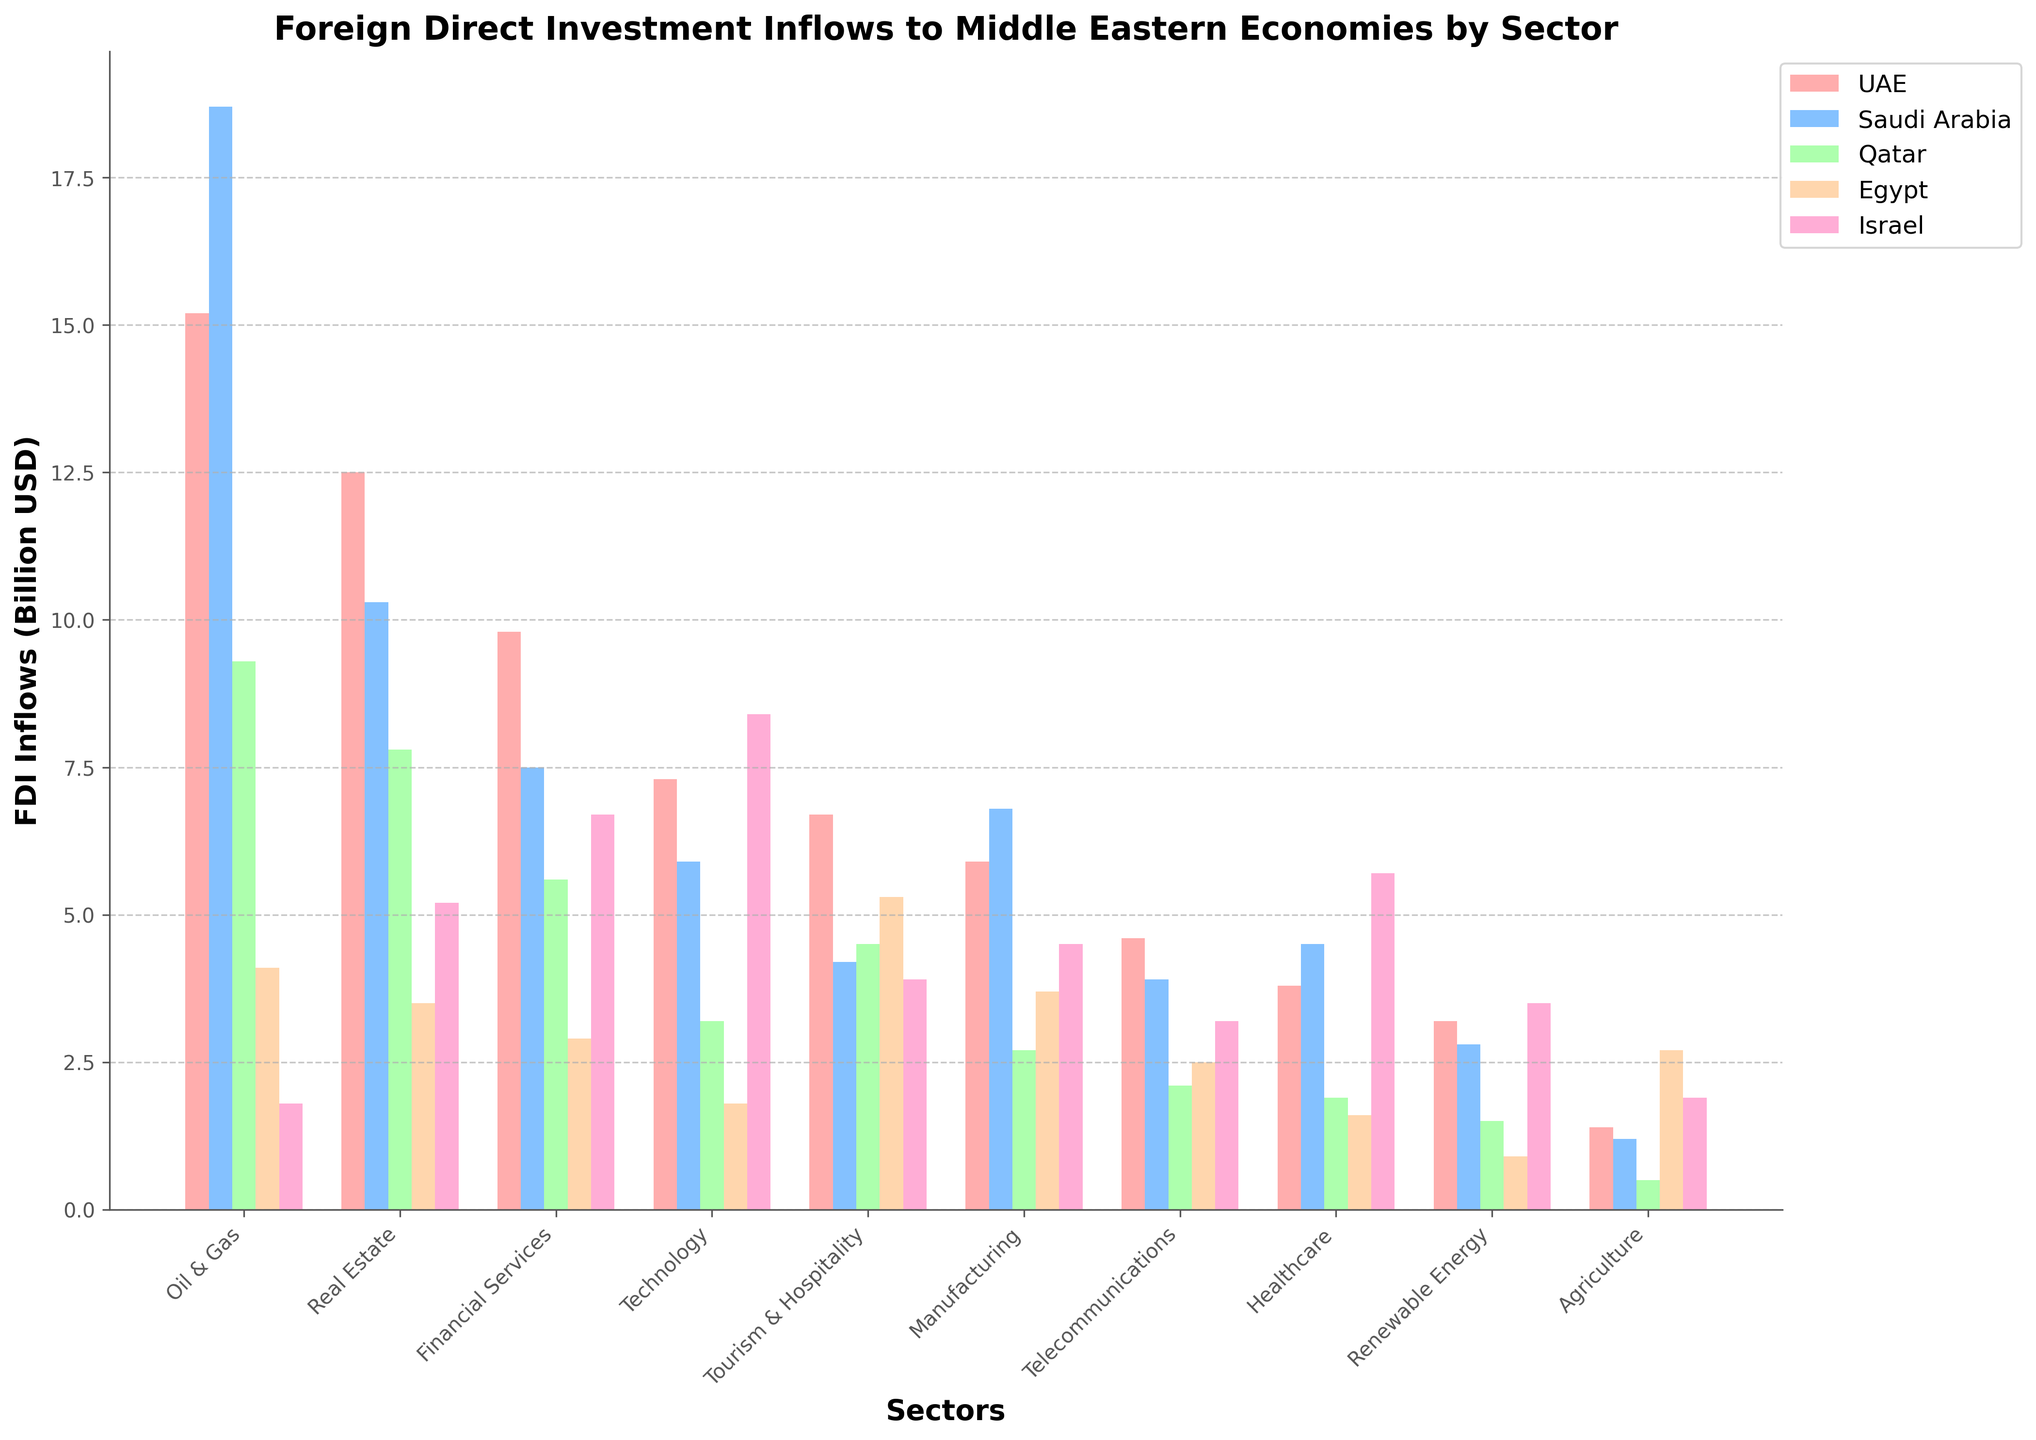Which sector receives the highest FDI inflows in the UAE? Look at the UAE's bars and identify the tallest one. Oil & Gas has the tallest bar.
Answer: Oil & Gas How do the FDI inflows for Financial Services compare between Egypt and Israel? Compare the height of the bars for Financial Services in Egypt (2.9) and Israel (6.7). Israel’s bar is taller.
Answer: Israel What's the sum of FDI inflows for Telecommunications and Agriculture in Saudi Arabia? Add the Saudi Arabia values for Telecommunications (3.9) and Agriculture (1.2): 3.9 + 1.2.
Answer: 5.1 Which country has the least FDI inflows in Technology? Find the shortest bar for Technology. Egypt has the shortest bar at 1.8.
Answer: Egypt Does the Manufacturing sector receive more FDI inflows than Renewable Energy in Qatar? Compare Manufacturing (2.7) and Renewable Energy (1.5) in Qatar. Manufacturing has higher values.
Answer: Yes Is the FDI inflow in Real Estate larger than in Tourism & Hospitality in Israel? Compare Real Estate (5.2) and Tourism & Hospitality (3.9) in Israel. Real Estate has the larger bar.
Answer: Yes What is the average FDI inflow for Oil & Gas, Real Estate, and Financial Services in the UAE? Sum the values for these sectors in UAE (15.2 + 12.5 + 9.8) and divide by 3: (37.5) / 3.
Answer: 12.5 Which sector has almost equal FDI inflows in both UAE and Saudi Arabia? Look for similar height bars in UAE and Saudi Arabia across sectors. Manufacturing has similar values: 5.9 (UAE), 6.8 (Saudi).
Answer: Manufacturing How does the FDI inflow in Healthcare for Israel compare with that in Saudi Arabia? Compare the bars for Healthcare in Israel (5.7) and Saudi Arabia (4.5). Israel has a taller bar.
Answer: Israel Which sector in Qatar gets more FDI inflow than their Telecommunications sector but less than Financial Services? Find sectors in Qatar that have more than 2.1 (Telecommunications) but less than 5.6 (Financial Services). Real Estate (7.8) does not qualify, but Tourism & Hospitality (4.5) does.
Answer: Tourism & Hospitality 